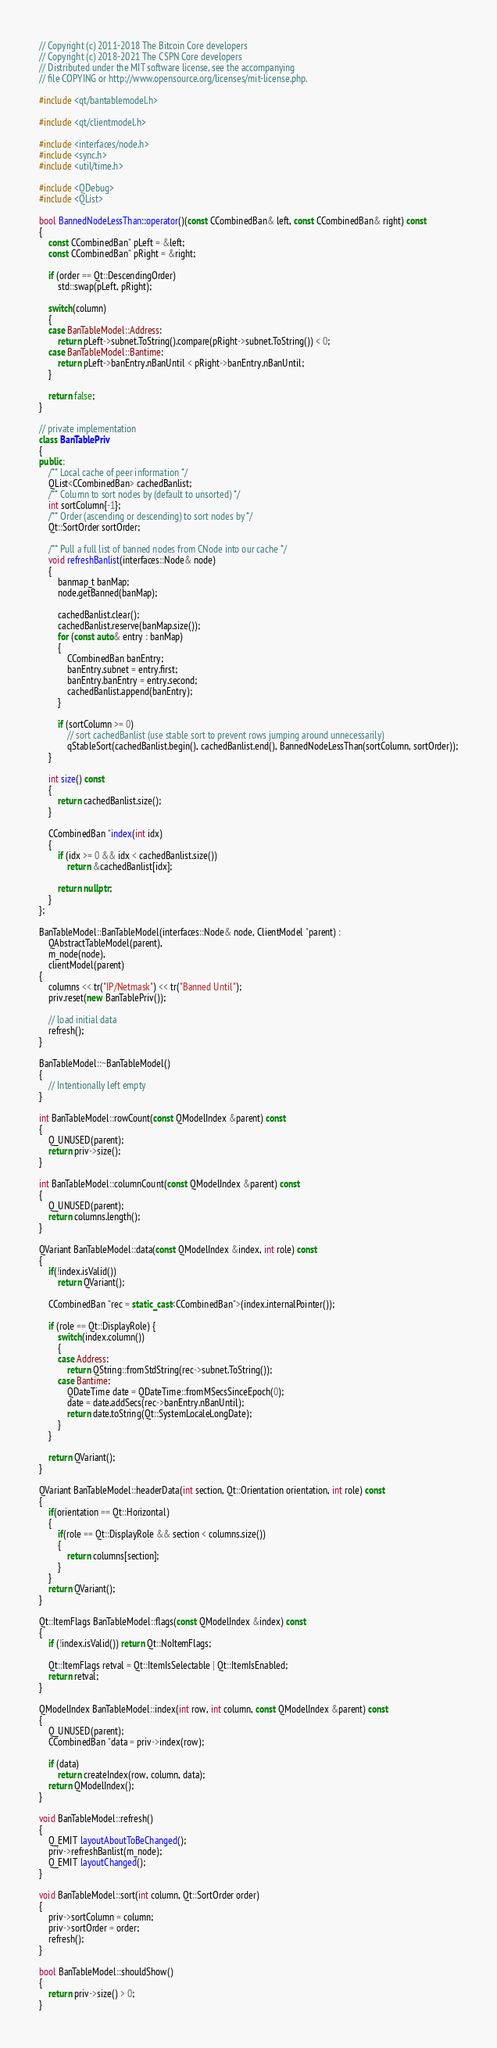Convert code to text. <code><loc_0><loc_0><loc_500><loc_500><_C++_>// Copyright (c) 2011-2018 The Bitcoin Core developers
// Copyright (c) 2018-2021 The CSPN Core developers
// Distributed under the MIT software license, see the accompanying
// file COPYING or http://www.opensource.org/licenses/mit-license.php.

#include <qt/bantablemodel.h>

#include <qt/clientmodel.h>

#include <interfaces/node.h>
#include <sync.h>
#include <util/time.h>

#include <QDebug>
#include <QList>

bool BannedNodeLessThan::operator()(const CCombinedBan& left, const CCombinedBan& right) const
{
    const CCombinedBan* pLeft = &left;
    const CCombinedBan* pRight = &right;

    if (order == Qt::DescendingOrder)
        std::swap(pLeft, pRight);

    switch(column)
    {
    case BanTableModel::Address:
        return pLeft->subnet.ToString().compare(pRight->subnet.ToString()) < 0;
    case BanTableModel::Bantime:
        return pLeft->banEntry.nBanUntil < pRight->banEntry.nBanUntil;
    }

    return false;
}

// private implementation
class BanTablePriv
{
public:
    /** Local cache of peer information */
    QList<CCombinedBan> cachedBanlist;
    /** Column to sort nodes by (default to unsorted) */
    int sortColumn{-1};
    /** Order (ascending or descending) to sort nodes by */
    Qt::SortOrder sortOrder;

    /** Pull a full list of banned nodes from CNode into our cache */
    void refreshBanlist(interfaces::Node& node)
    {
        banmap_t banMap;
        node.getBanned(banMap);

        cachedBanlist.clear();
        cachedBanlist.reserve(banMap.size());
        for (const auto& entry : banMap)
        {
            CCombinedBan banEntry;
            banEntry.subnet = entry.first;
            banEntry.banEntry = entry.second;
            cachedBanlist.append(banEntry);
        }

        if (sortColumn >= 0)
            // sort cachedBanlist (use stable sort to prevent rows jumping around unnecessarily)
            qStableSort(cachedBanlist.begin(), cachedBanlist.end(), BannedNodeLessThan(sortColumn, sortOrder));
    }

    int size() const
    {
        return cachedBanlist.size();
    }

    CCombinedBan *index(int idx)
    {
        if (idx >= 0 && idx < cachedBanlist.size())
            return &cachedBanlist[idx];

        return nullptr;
    }
};

BanTableModel::BanTableModel(interfaces::Node& node, ClientModel *parent) :
    QAbstractTableModel(parent),
    m_node(node),
    clientModel(parent)
{
    columns << tr("IP/Netmask") << tr("Banned Until");
    priv.reset(new BanTablePriv());

    // load initial data
    refresh();
}

BanTableModel::~BanTableModel()
{
    // Intentionally left empty
}

int BanTableModel::rowCount(const QModelIndex &parent) const
{
    Q_UNUSED(parent);
    return priv->size();
}

int BanTableModel::columnCount(const QModelIndex &parent) const
{
    Q_UNUSED(parent);
    return columns.length();
}

QVariant BanTableModel::data(const QModelIndex &index, int role) const
{
    if(!index.isValid())
        return QVariant();

    CCombinedBan *rec = static_cast<CCombinedBan*>(index.internalPointer());

    if (role == Qt::DisplayRole) {
        switch(index.column())
        {
        case Address:
            return QString::fromStdString(rec->subnet.ToString());
        case Bantime:
            QDateTime date = QDateTime::fromMSecsSinceEpoch(0);
            date = date.addSecs(rec->banEntry.nBanUntil);
            return date.toString(Qt::SystemLocaleLongDate);
        }
    }

    return QVariant();
}

QVariant BanTableModel::headerData(int section, Qt::Orientation orientation, int role) const
{
    if(orientation == Qt::Horizontal)
    {
        if(role == Qt::DisplayRole && section < columns.size())
        {
            return columns[section];
        }
    }
    return QVariant();
}

Qt::ItemFlags BanTableModel::flags(const QModelIndex &index) const
{
    if (!index.isValid()) return Qt::NoItemFlags;

    Qt::ItemFlags retval = Qt::ItemIsSelectable | Qt::ItemIsEnabled;
    return retval;
}

QModelIndex BanTableModel::index(int row, int column, const QModelIndex &parent) const
{
    Q_UNUSED(parent);
    CCombinedBan *data = priv->index(row);

    if (data)
        return createIndex(row, column, data);
    return QModelIndex();
}

void BanTableModel::refresh()
{
    Q_EMIT layoutAboutToBeChanged();
    priv->refreshBanlist(m_node);
    Q_EMIT layoutChanged();
}

void BanTableModel::sort(int column, Qt::SortOrder order)
{
    priv->sortColumn = column;
    priv->sortOrder = order;
    refresh();
}

bool BanTableModel::shouldShow()
{
    return priv->size() > 0;
}
</code> 